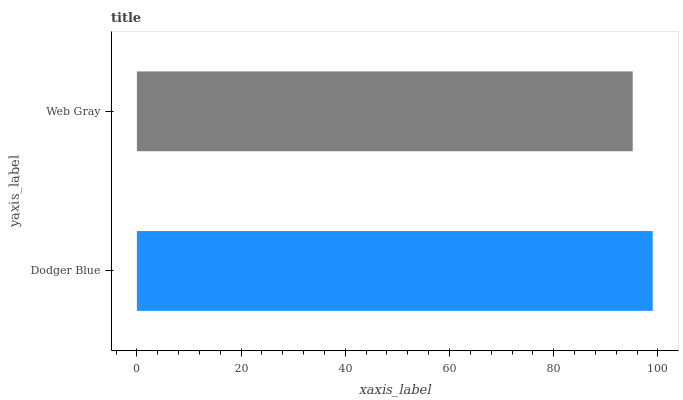Is Web Gray the minimum?
Answer yes or no. Yes. Is Dodger Blue the maximum?
Answer yes or no. Yes. Is Web Gray the maximum?
Answer yes or no. No. Is Dodger Blue greater than Web Gray?
Answer yes or no. Yes. Is Web Gray less than Dodger Blue?
Answer yes or no. Yes. Is Web Gray greater than Dodger Blue?
Answer yes or no. No. Is Dodger Blue less than Web Gray?
Answer yes or no. No. Is Dodger Blue the high median?
Answer yes or no. Yes. Is Web Gray the low median?
Answer yes or no. Yes. Is Web Gray the high median?
Answer yes or no. No. Is Dodger Blue the low median?
Answer yes or no. No. 